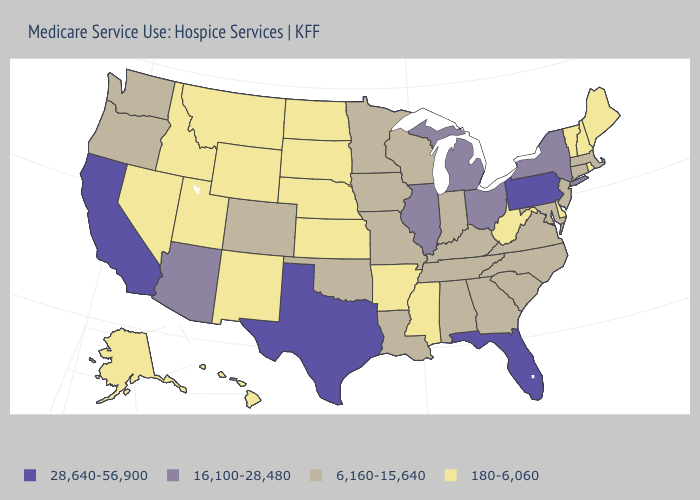What is the value of New Hampshire?
Short answer required. 180-6,060. Does New Hampshire have a lower value than West Virginia?
Be succinct. No. Does Kansas have the lowest value in the MidWest?
Quick response, please. Yes. What is the value of West Virginia?
Answer briefly. 180-6,060. Does South Dakota have the lowest value in the MidWest?
Give a very brief answer. Yes. Which states have the highest value in the USA?
Write a very short answer. California, Florida, Pennsylvania, Texas. What is the highest value in states that border New Jersey?
Short answer required. 28,640-56,900. What is the lowest value in the USA?
Write a very short answer. 180-6,060. What is the value of Vermont?
Write a very short answer. 180-6,060. Which states have the lowest value in the USA?
Keep it brief. Alaska, Arkansas, Delaware, Hawaii, Idaho, Kansas, Maine, Mississippi, Montana, Nebraska, Nevada, New Hampshire, New Mexico, North Dakota, Rhode Island, South Dakota, Utah, Vermont, West Virginia, Wyoming. Which states have the lowest value in the USA?
Write a very short answer. Alaska, Arkansas, Delaware, Hawaii, Idaho, Kansas, Maine, Mississippi, Montana, Nebraska, Nevada, New Hampshire, New Mexico, North Dakota, Rhode Island, South Dakota, Utah, Vermont, West Virginia, Wyoming. Does Nebraska have a lower value than Arkansas?
Give a very brief answer. No. Does Maine have the highest value in the USA?
Be succinct. No. What is the highest value in states that border South Carolina?
Keep it brief. 6,160-15,640. 